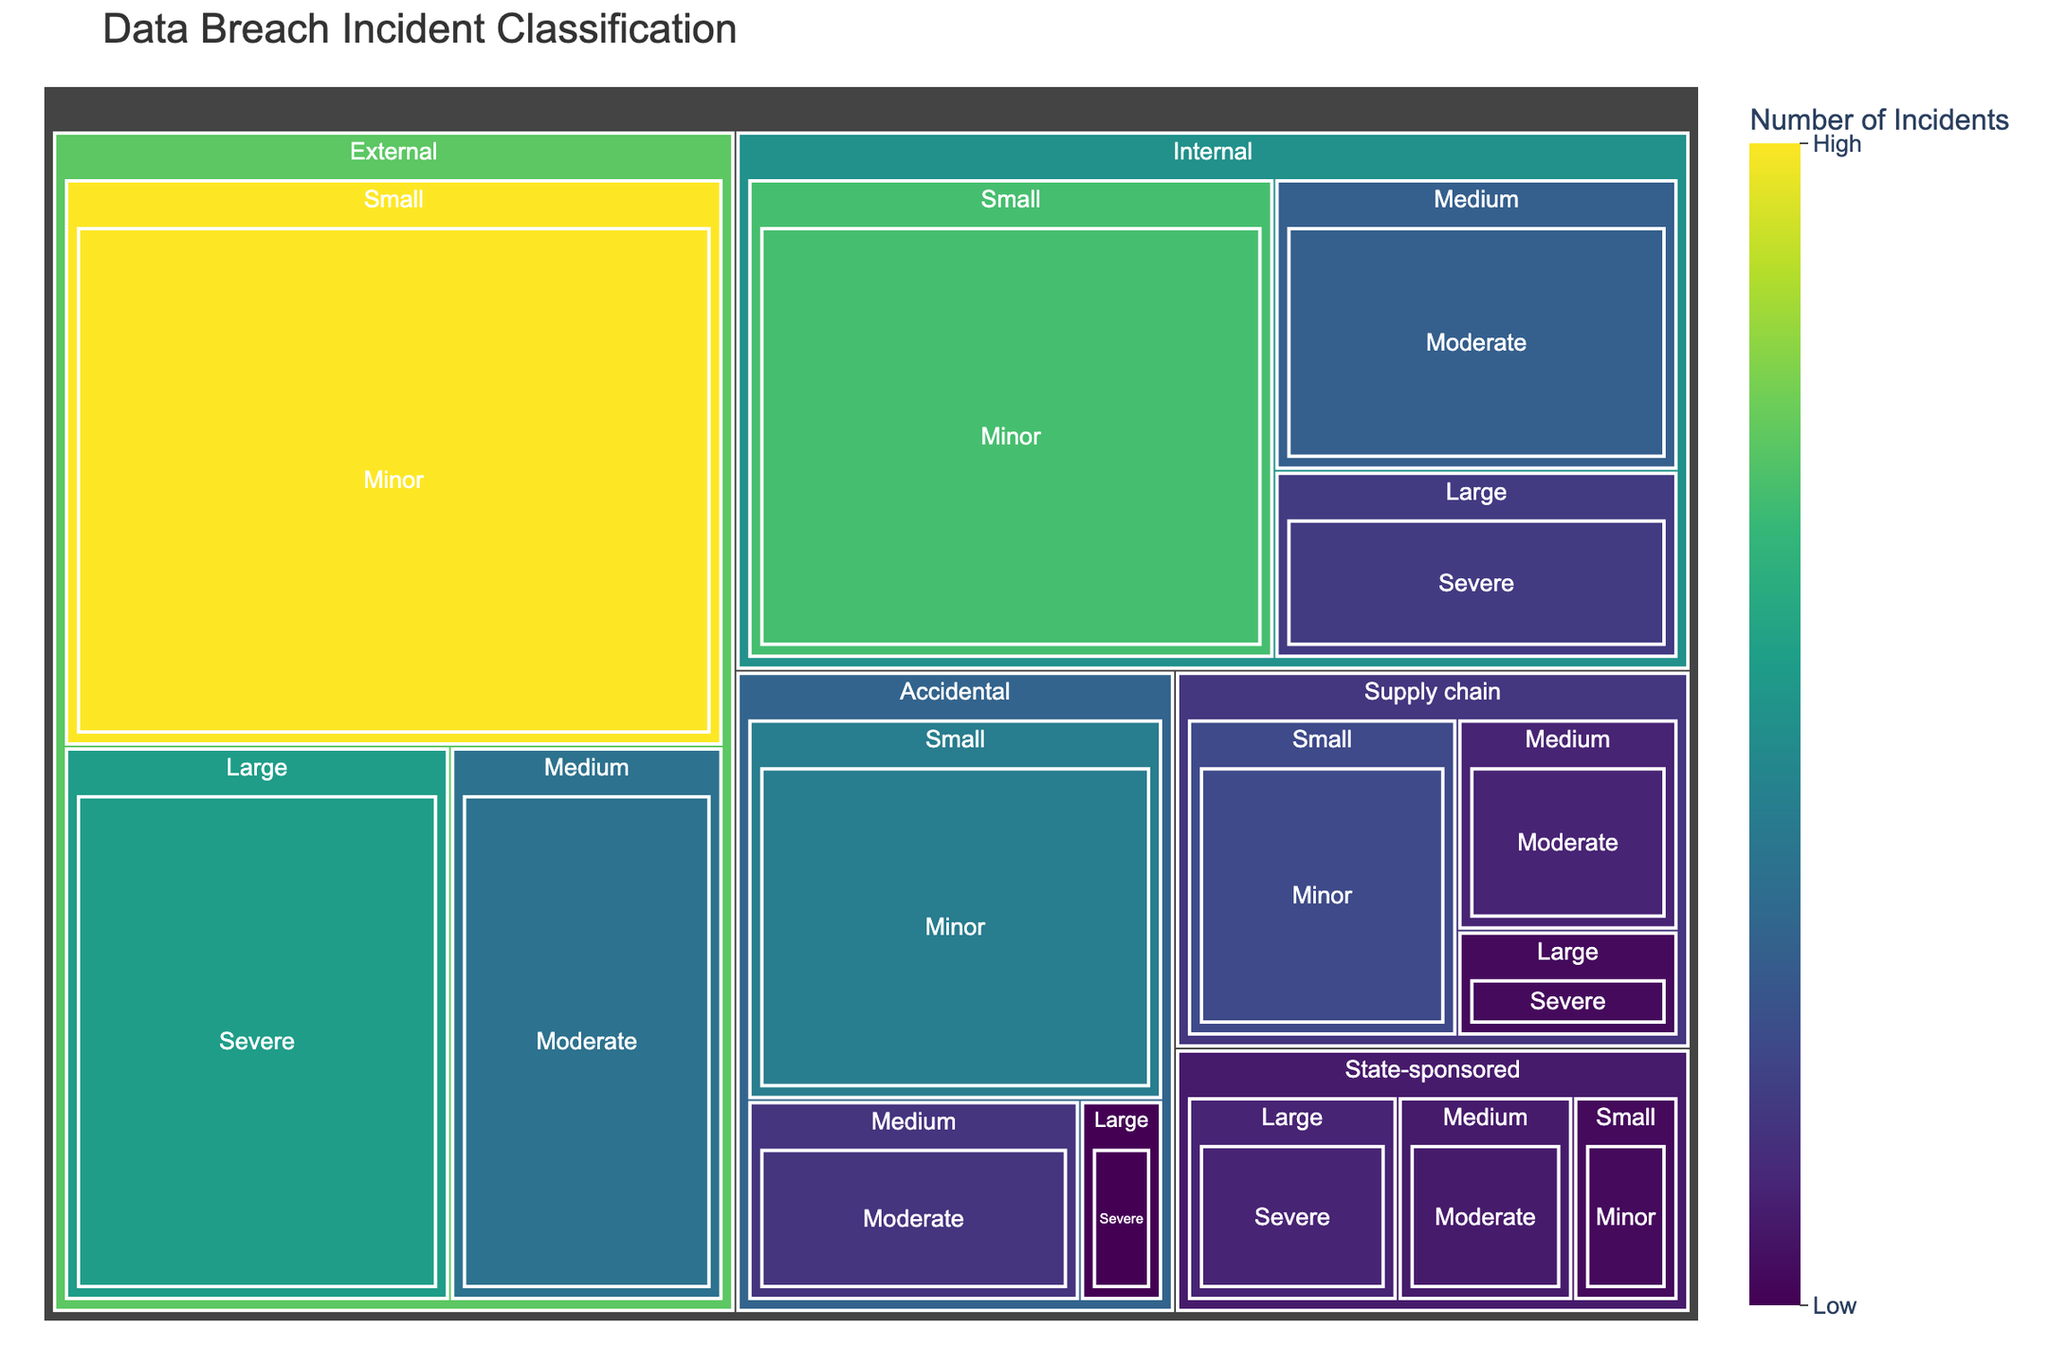What is the total number of data breach incidents represented in the treemap? To find the total number of data breach incidents, you need to sum the number of incidents from all categories. Add 120 (External, Large) + 85 (External, Medium) + 210 (External, Small) + 45 (Internal, Large) + 70 (Internal, Medium) + 150 (Internal, Small) + 30 (State-sponsored, Large) + 25 (State-sponsored, Medium) + 15 (State-sponsored, Small) + 10 (Accidental, Large) + 40 (Accidental, Medium) + 95 (Accidental, Small) + 15 (Supply chain, Large) + 30 (Supply chain, Medium) + 55 (Supply chain, Small). This totals to 995.
Answer: 995 Which category has the highest number of incidents? To identify the category with the highest number of incidents, look for the plot section with the largest area or the highest value. External, Small has 210 incidents highlighted in the treemap as the largest section.
Answer: External, Small How many severe large-scale data breaches are depicted in the treemap? Count the sections labeled as "Severe" and "Large." The treemap shows four categories for this: External (120), Internal (45), State-sponsored (30), and Accidental (10). The total is 120 + 45 + 30 + 10 = 205.
Answer: 205 Are there more internal or accidental medium-scale moderate impact breaches? Compare the values for Internal, Medium, Moderate (70) and Accidental, Medium, Moderate (40). Internal, Medium, Moderate has more incidents.
Answer: Internal, Medium, Moderate Which category has the fewest incidents, and how many? The smallest value represented in the treemap is the one with the fewest incidents. This is found under the category State-sponsored, Small with 15 incidents.
Answer: State-sponsored, Small; 15 What is the average number of incidents for all state-sponsored breaches? To find the average, sum the incidents for State-sponsored breaches and divide by the number of categories (Large, Medium, Small). The values are 30 (Large) + 25 (Medium) + 15 (Small). Sum is 30 + 25 + 15 = 70. There are 3 categories, so average is 70 / 3 ≈ 23.33.
Answer: 23.33 Is the number of external, small-scale minor breaches greater than the combined total of all accidental breaches? External, Small, Minor has 210 incidents. For accidental breaches, sum all incidences: Large (10), Medium (40), Small (95). Total is 10 + 40 + 95 = 145. Thus, 210 > 145.
Answer: Yes Compare the total number of breaches for internal and external origin. Which is greater? Compare the sum of breaches for Internal and External origins. Internal: 45 (Large) + 70 (Medium) + 150 (Small) = 265; External: 120 (Large) + 85 (Medium) + 210 (Small) = 415. External is greater.
Answer: External How many incidents are associated with supply chain minor impact breaches? The treemap indicates that Supply chain, Small, Minor breaches account for 55 incidents.
Answer: 55 